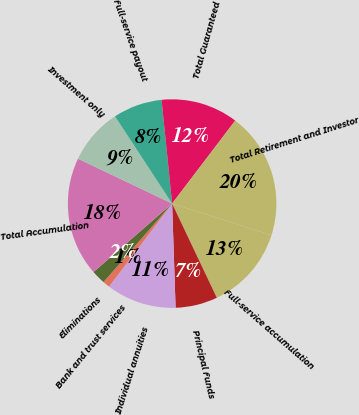Convert chart. <chart><loc_0><loc_0><loc_500><loc_500><pie_chart><fcel>Full-service accumulation<fcel>Principal Funds<fcel>Individual annuities<fcel>Bank and trust services<fcel>Eliminations<fcel>Total Accumulation<fcel>Investment only<fcel>Full-service payout<fcel>Total Guaranteed<fcel>Total Retirement and Investor<nl><fcel>13.04%<fcel>6.52%<fcel>10.87%<fcel>1.09%<fcel>2.17%<fcel>18.48%<fcel>8.7%<fcel>7.61%<fcel>11.96%<fcel>19.56%<nl></chart> 